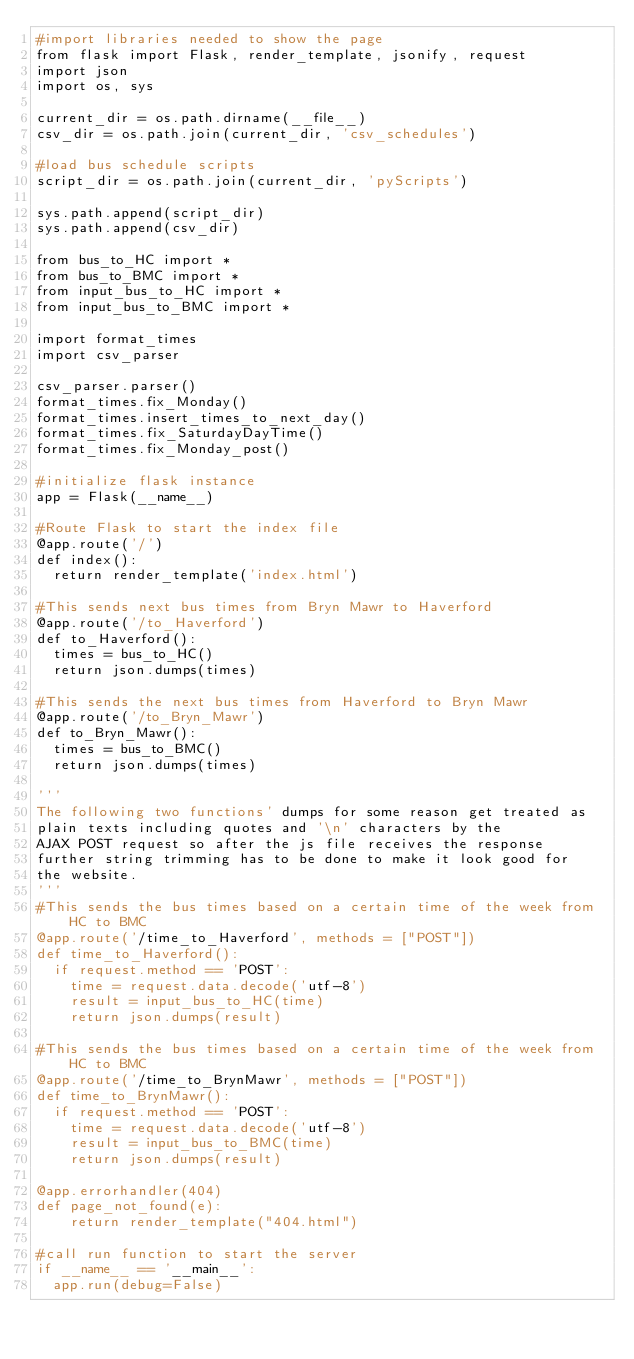<code> <loc_0><loc_0><loc_500><loc_500><_Python_>#import libraries needed to show the page
from flask import Flask, render_template, jsonify, request
import json
import os, sys

current_dir = os.path.dirname(__file__)
csv_dir = os.path.join(current_dir, 'csv_schedules')

#load bus schedule scripts
script_dir = os.path.join(current_dir, 'pyScripts')

sys.path.append(script_dir)
sys.path.append(csv_dir)

from bus_to_HC import *
from bus_to_BMC import *
from input_bus_to_HC import *
from input_bus_to_BMC import *

import format_times
import csv_parser

csv_parser.parser()
format_times.fix_Monday()
format_times.insert_times_to_next_day()
format_times.fix_SaturdayDayTime()
format_times.fix_Monday_post()

#initialize flask instance
app = Flask(__name__)

#Route Flask to start the index file
@app.route('/')
def index():
	return render_template('index.html')

#This sends next bus times from Bryn Mawr to Haverford
@app.route('/to_Haverford')
def to_Haverford():
	times = bus_to_HC()
	return json.dumps(times)

#This sends the next bus times from Haverford to Bryn Mawr
@app.route('/to_Bryn_Mawr')
def to_Bryn_Mawr():
	times = bus_to_BMC()
	return json.dumps(times)

'''
The following two functions' dumps for some reason get treated as
plain texts including quotes and '\n' characters by the 
AJAX POST request so after the js file receives the response
further string trimming has to be done to make it look good for 
the website.
'''
#This sends the bus times based on a certain time of the week from HC to BMC
@app.route('/time_to_Haverford', methods = ["POST"])
def time_to_Haverford():
	if request.method == 'POST':
		time = request.data.decode('utf-8')
		result = input_bus_to_HC(time)
		return json.dumps(result)

#This sends the bus times based on a certain time of the week from HC to BMC
@app.route('/time_to_BrynMawr', methods = ["POST"])
def time_to_BrynMawr():
	if request.method == 'POST':
		time = request.data.decode('utf-8')
		result = input_bus_to_BMC(time)
		return json.dumps(result)

@app.errorhandler(404)
def page_not_found(e):
    return render_template("404.html")

#call run function to start the server
if __name__ == '__main__':
	app.run(debug=False)
</code> 